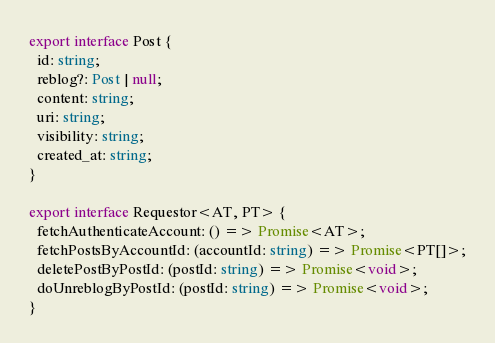<code> <loc_0><loc_0><loc_500><loc_500><_TypeScript_>
export interface Post {
  id: string;
  reblog?: Post | null;
  content: string;
  uri: string;
  visibility: string;
  created_at: string;
}

export interface Requestor<AT, PT> {
  fetchAuthenticateAccount: () => Promise<AT>;
  fetchPostsByAccountId: (accountId: string) => Promise<PT[]>;
  deletePostByPostId: (postId: string) => Promise<void>;
  doUnreblogByPostId: (postId: string) => Promise<void>;
}
</code> 